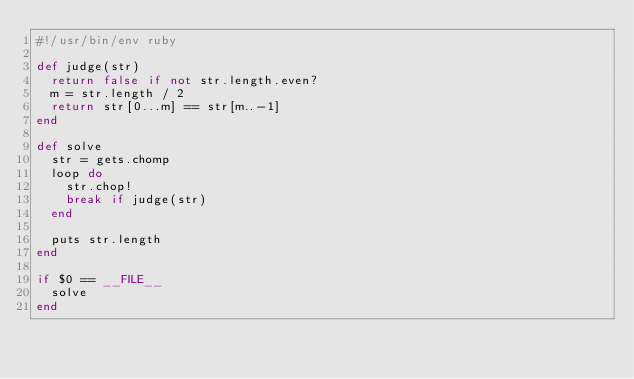Convert code to text. <code><loc_0><loc_0><loc_500><loc_500><_Ruby_>#!/usr/bin/env ruby

def judge(str)
  return false if not str.length.even?
  m = str.length / 2
  return str[0...m] == str[m..-1]
end

def solve
  str = gets.chomp
  loop do
    str.chop!
    break if judge(str)
  end

  puts str.length
end

if $0 == __FILE__
  solve
end
</code> 